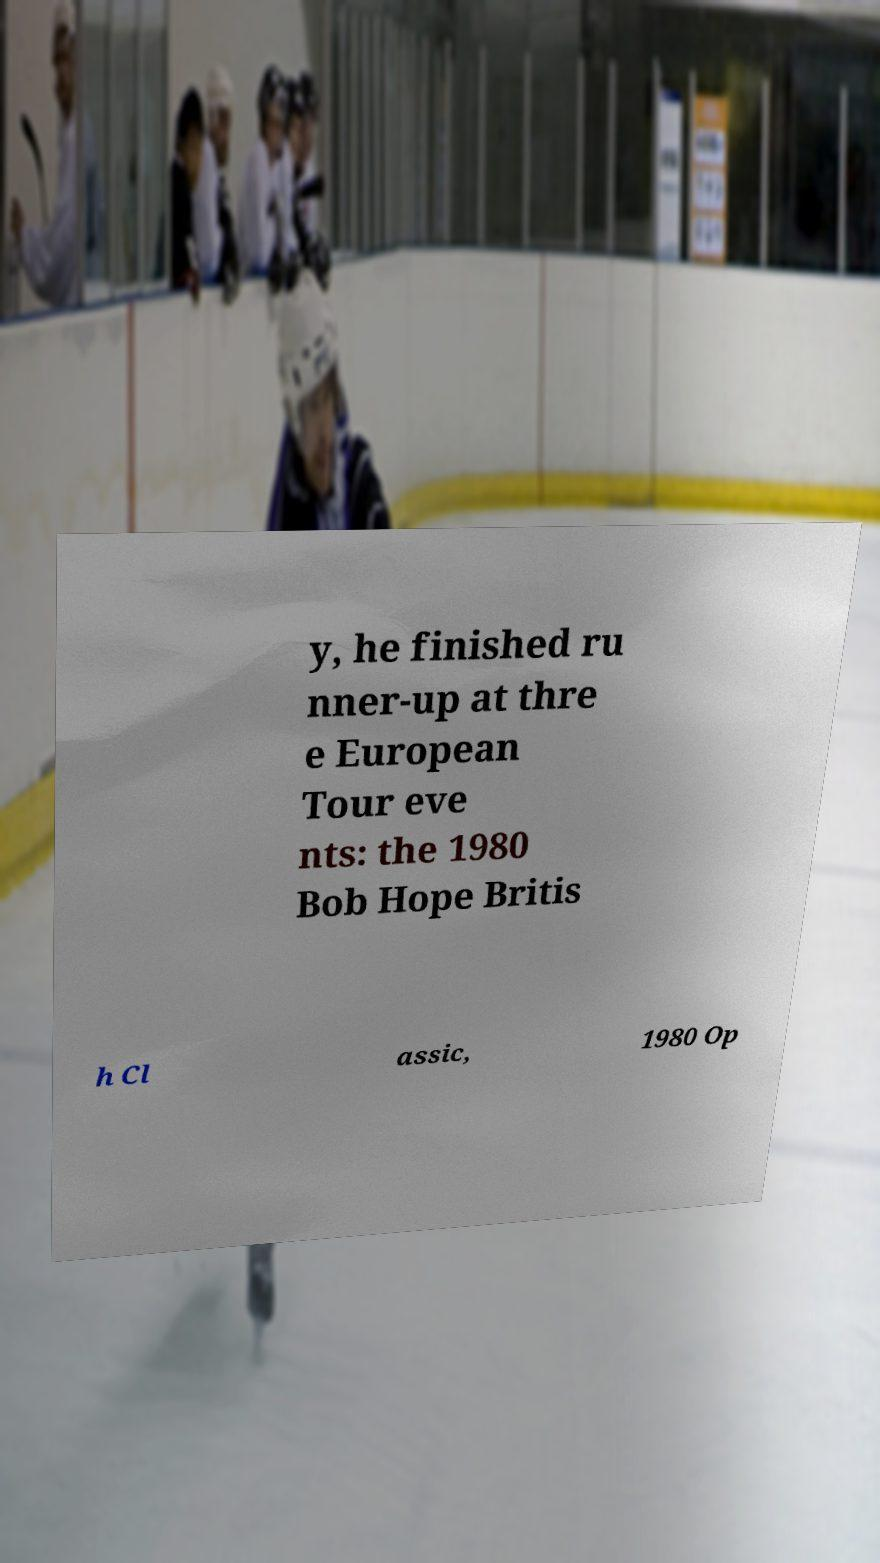Can you accurately transcribe the text from the provided image for me? y, he finished ru nner-up at thre e European Tour eve nts: the 1980 Bob Hope Britis h Cl assic, 1980 Op 